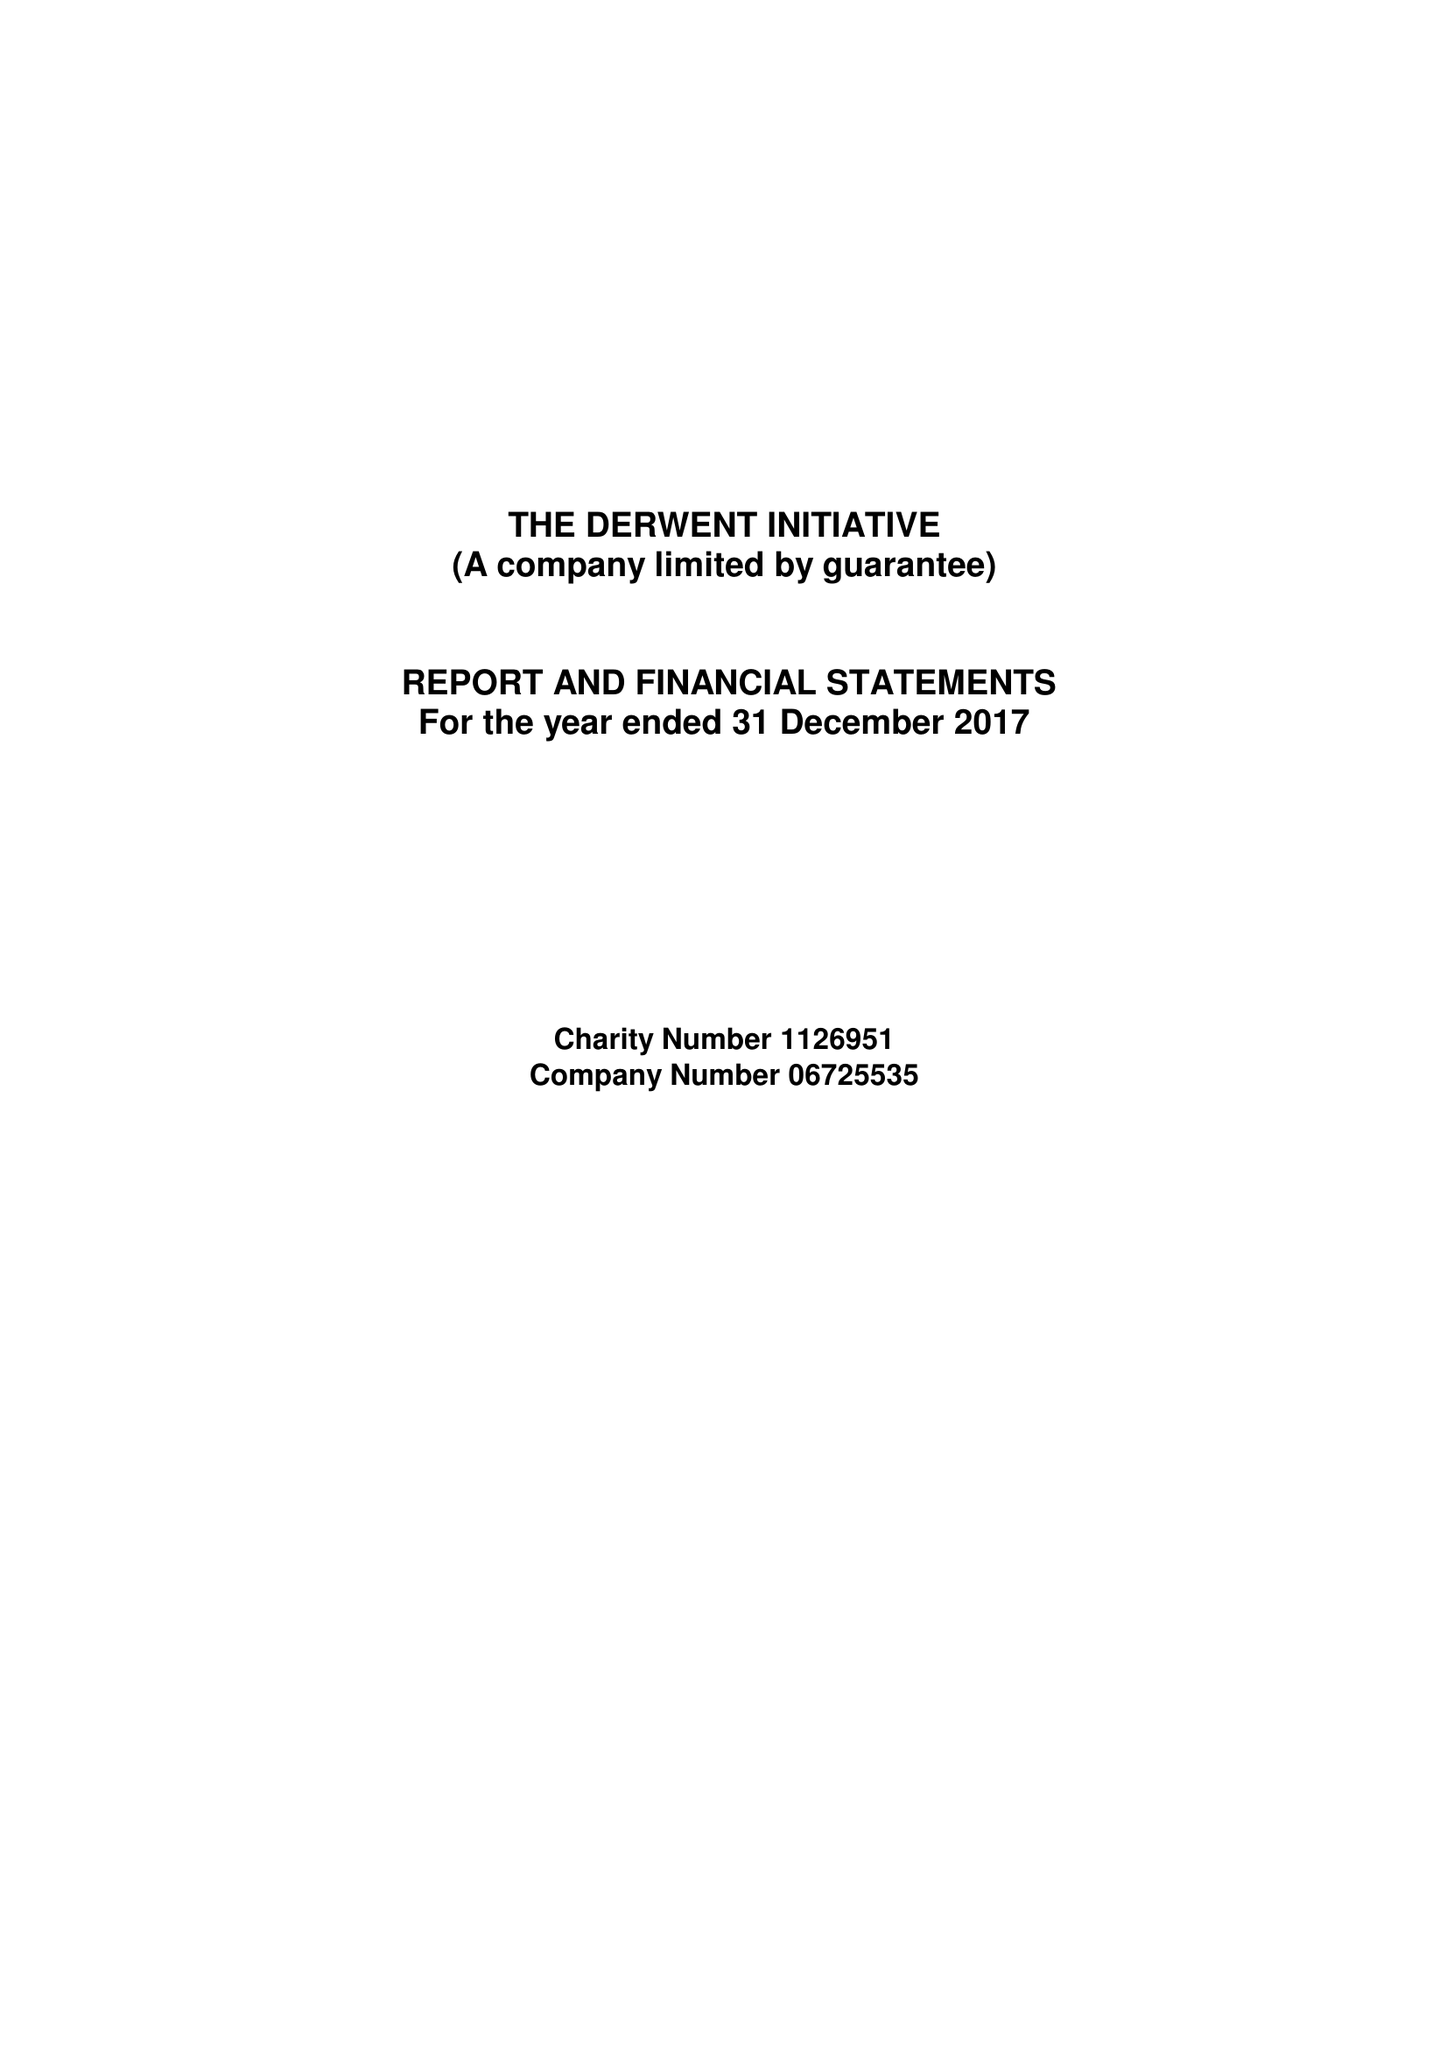What is the value for the address__street_line?
Answer the question using a single word or phrase. None 